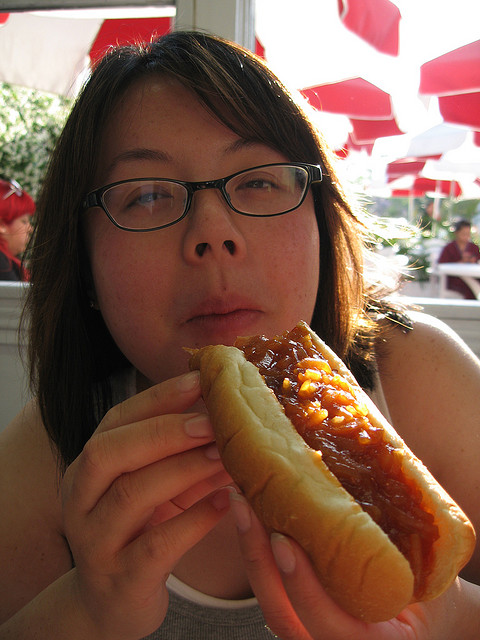How many people are visible? There is one person visible in the image. 